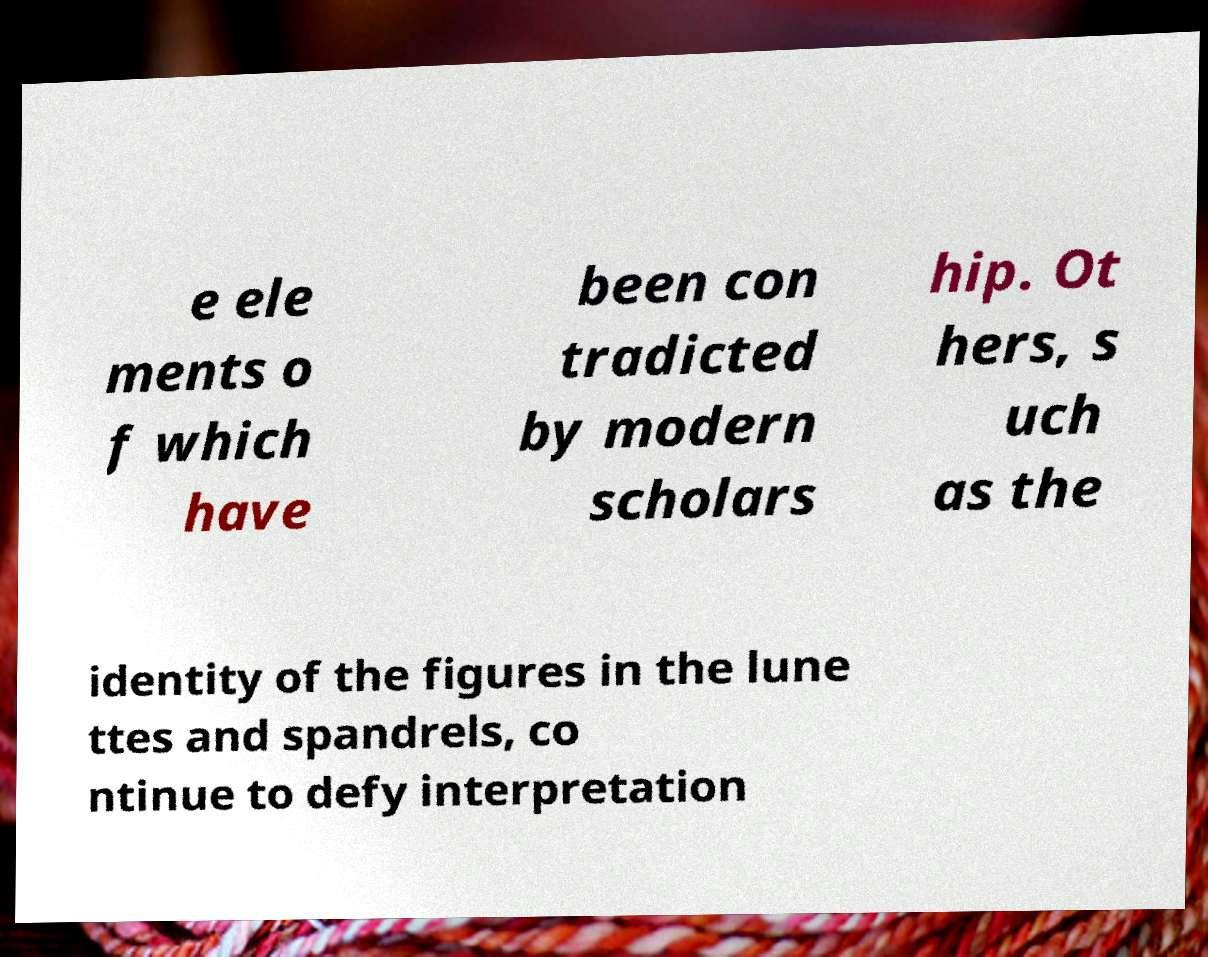Could you extract and type out the text from this image? e ele ments o f which have been con tradicted by modern scholars hip. Ot hers, s uch as the identity of the figures in the lune ttes and spandrels, co ntinue to defy interpretation 